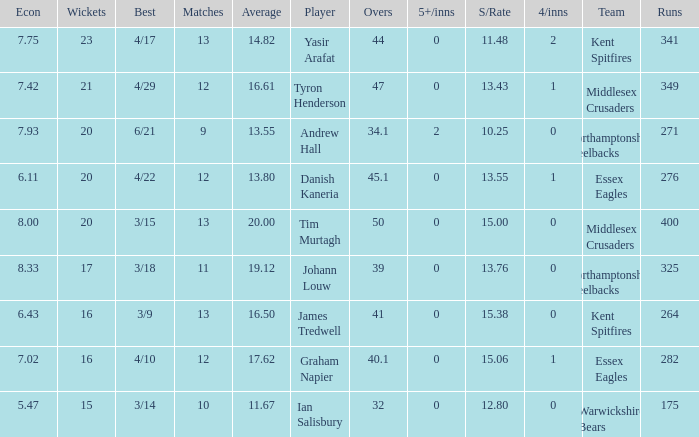Name the most wickets for best is 4/22 20.0. 